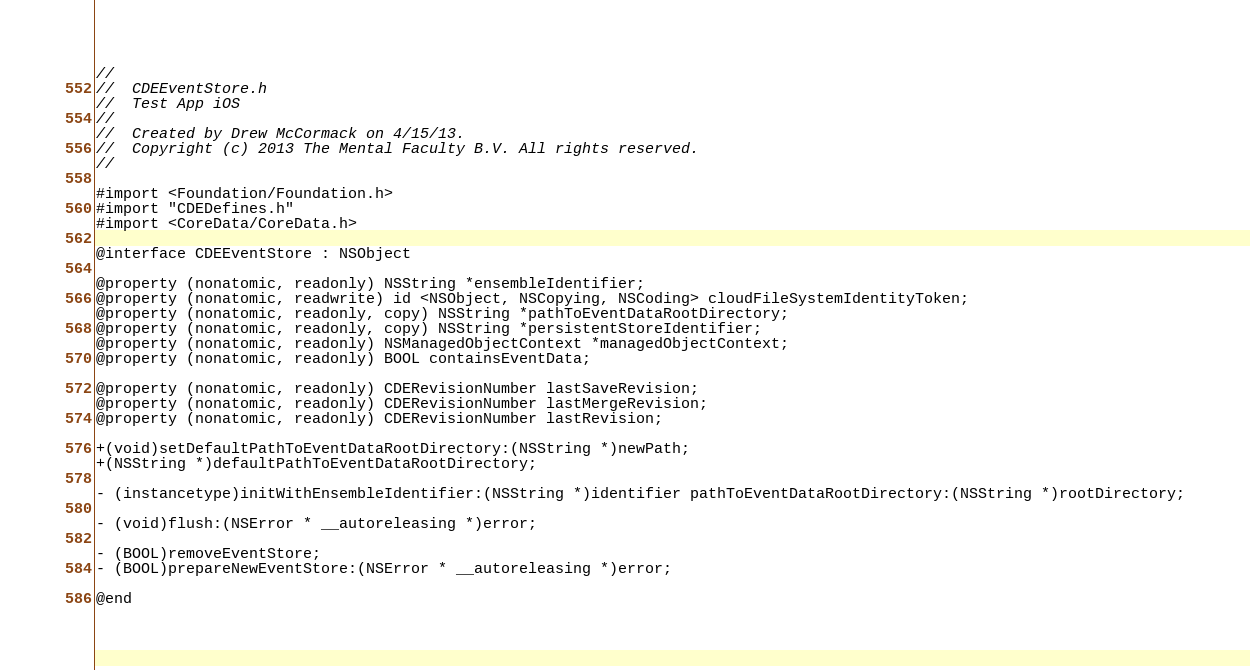<code> <loc_0><loc_0><loc_500><loc_500><_C_>//
//  CDEEventStore.h
//  Test App iOS
//
//  Created by Drew McCormack on 4/15/13.
//  Copyright (c) 2013 The Mental Faculty B.V. All rights reserved.
//

#import <Foundation/Foundation.h>
#import "CDEDefines.h"
#import <CoreData/CoreData.h>

@interface CDEEventStore : NSObject

@property (nonatomic, readonly) NSString *ensembleIdentifier;
@property (nonatomic, readwrite) id <NSObject, NSCopying, NSCoding> cloudFileSystemIdentityToken;
@property (nonatomic, readonly, copy) NSString *pathToEventDataRootDirectory;
@property (nonatomic, readonly, copy) NSString *persistentStoreIdentifier;
@property (nonatomic, readonly) NSManagedObjectContext *managedObjectContext;
@property (nonatomic, readonly) BOOL containsEventData;

@property (nonatomic, readonly) CDERevisionNumber lastSaveRevision;
@property (nonatomic, readonly) CDERevisionNumber lastMergeRevision;
@property (nonatomic, readonly) CDERevisionNumber lastRevision;

+(void)setDefaultPathToEventDataRootDirectory:(NSString *)newPath;
+(NSString *)defaultPathToEventDataRootDirectory;

- (instancetype)initWithEnsembleIdentifier:(NSString *)identifier pathToEventDataRootDirectory:(NSString *)rootDirectory;

- (void)flush:(NSError * __autoreleasing *)error;

- (BOOL)removeEventStore;
- (BOOL)prepareNewEventStore:(NSError * __autoreleasing *)error;

@end
</code> 